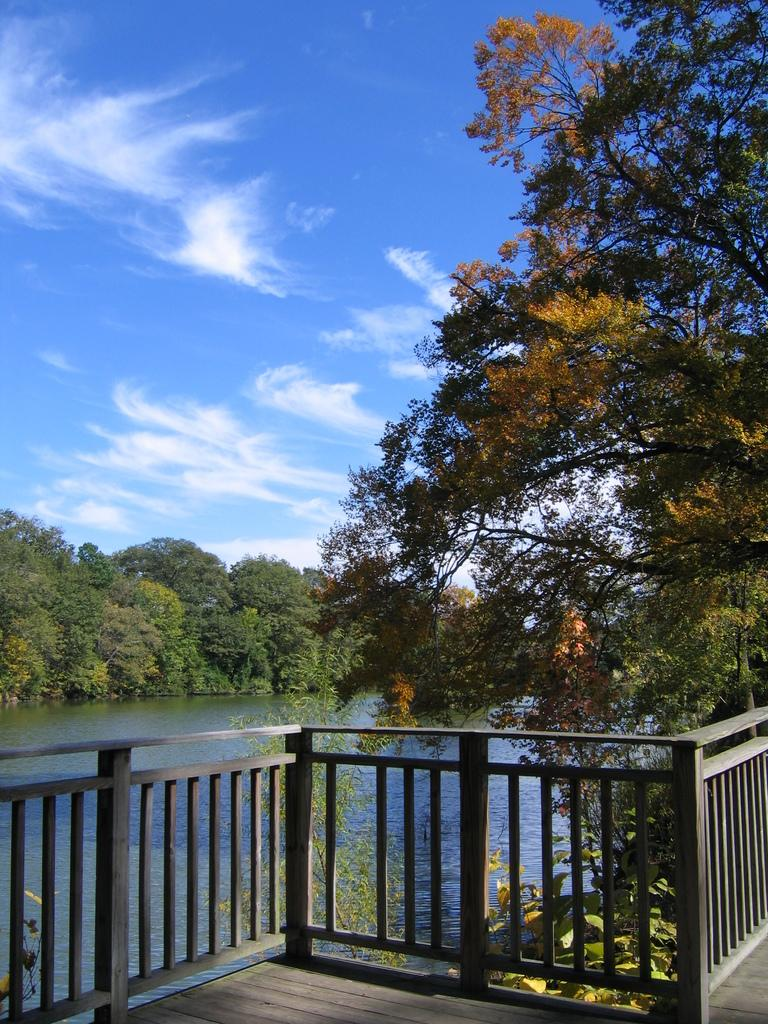What is located at the front of the image? There is a railing in the front of the image. What can be seen in the center of the image? There are trees and a lake in the center of the image. What is visible in the background of the image? There are trees and a cloudy sky in the background of the image. Where is the crib located in the image? There is no crib present in the image. What type of class is being held near the trees in the image? There is no class or any indication of an educational activity in the image. 